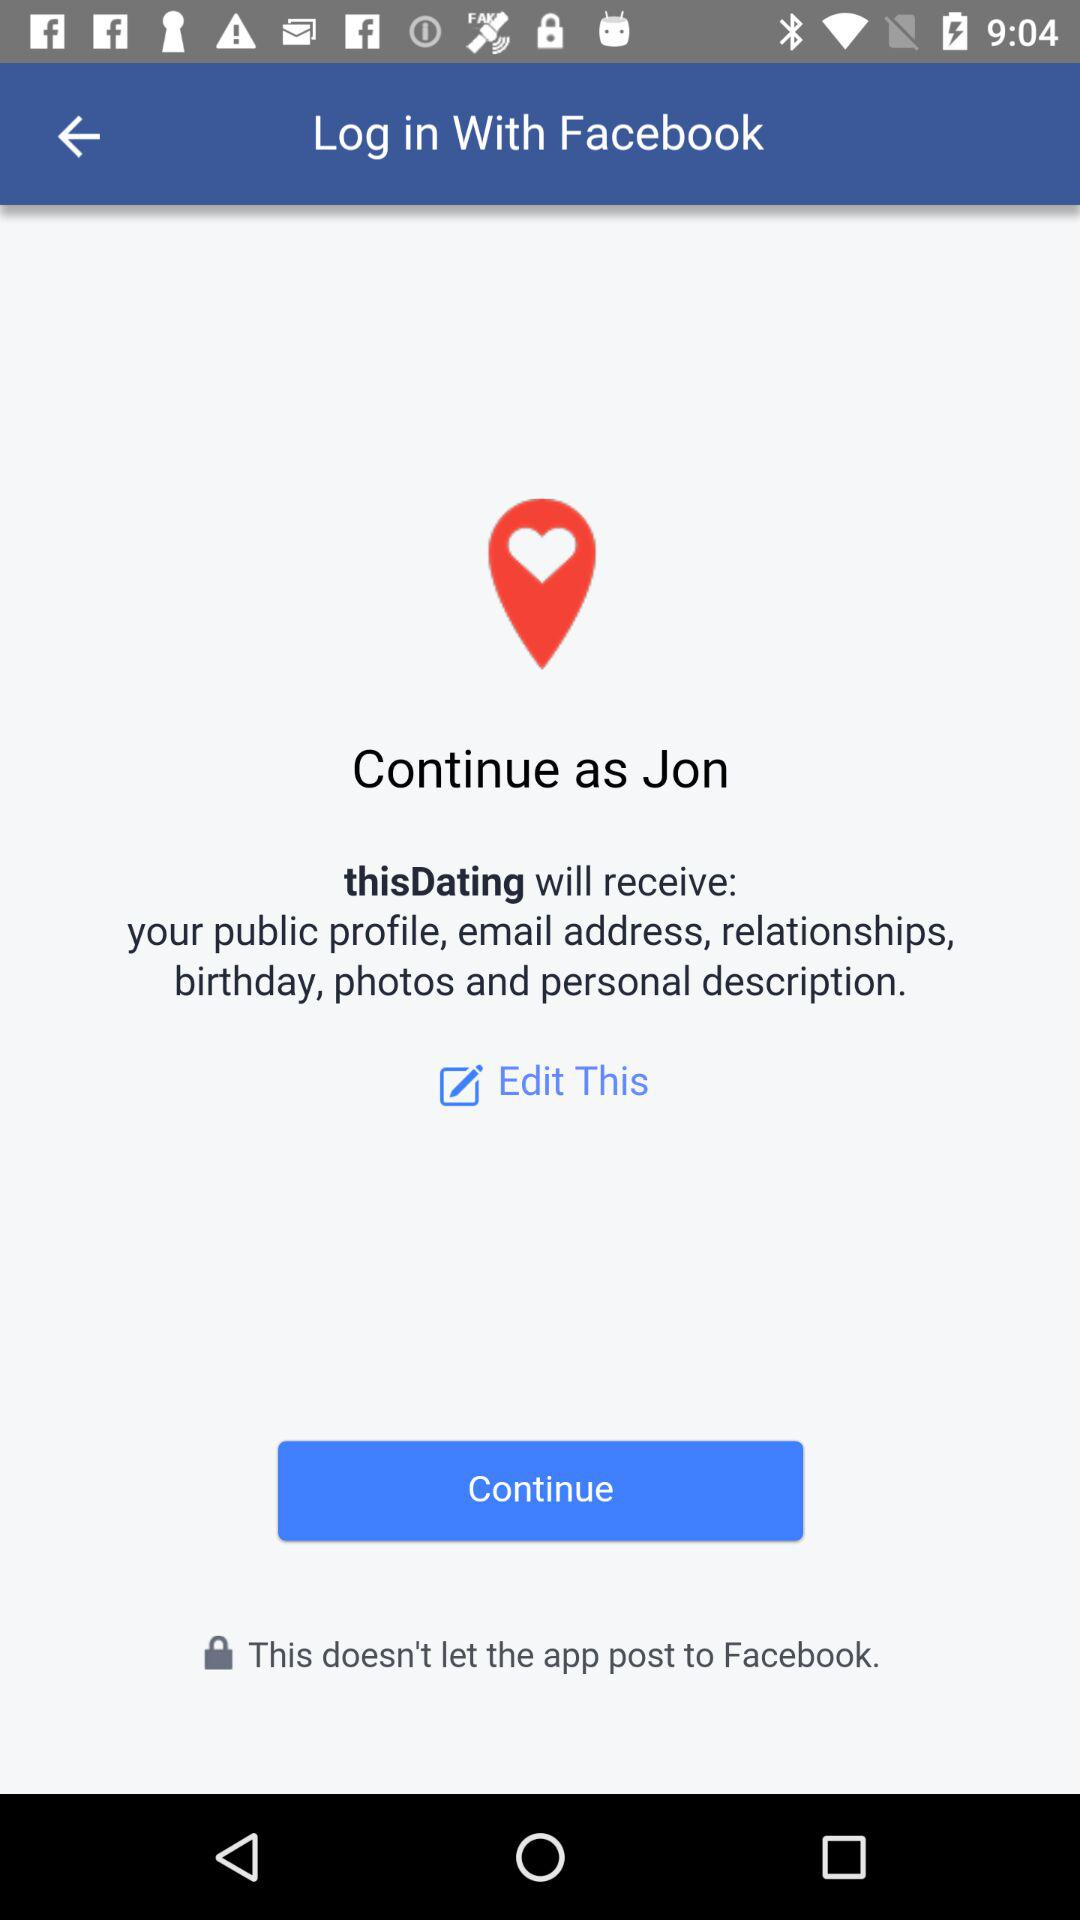Who will receive the public profile, email address and photos? The application "thisDating" will receive the public profile, email address and photos. 